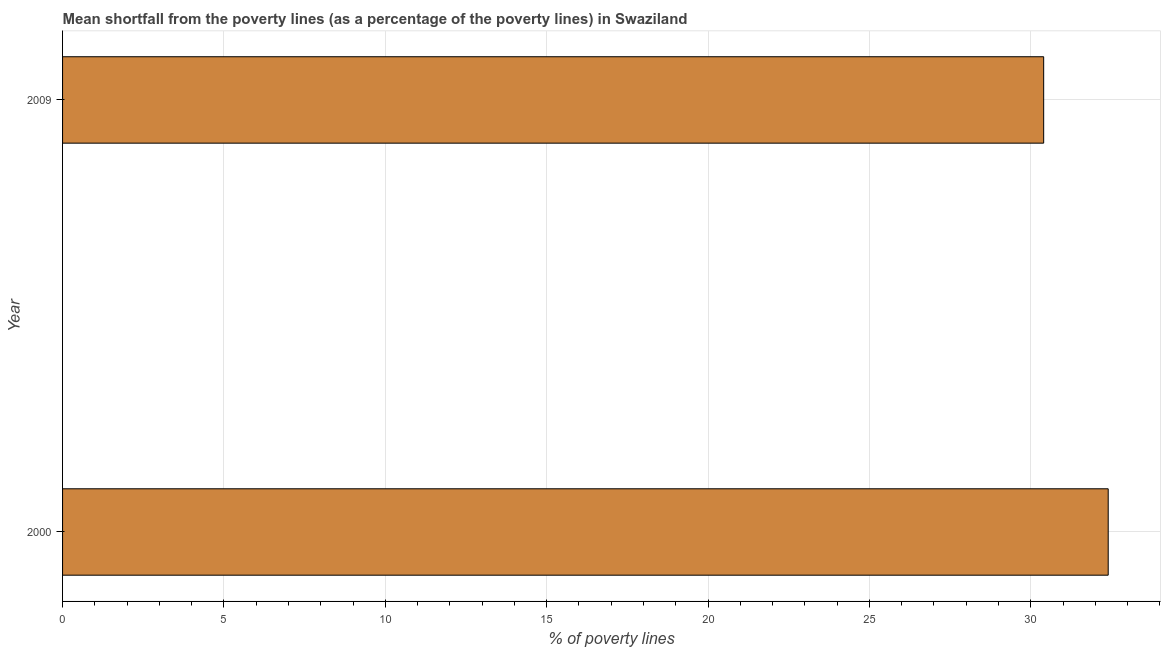What is the title of the graph?
Make the answer very short. Mean shortfall from the poverty lines (as a percentage of the poverty lines) in Swaziland. What is the label or title of the X-axis?
Ensure brevity in your answer.  % of poverty lines. What is the poverty gap at national poverty lines in 2000?
Your answer should be very brief. 32.4. Across all years, what is the maximum poverty gap at national poverty lines?
Your answer should be compact. 32.4. Across all years, what is the minimum poverty gap at national poverty lines?
Your answer should be very brief. 30.4. In which year was the poverty gap at national poverty lines maximum?
Your answer should be compact. 2000. In which year was the poverty gap at national poverty lines minimum?
Offer a very short reply. 2009. What is the sum of the poverty gap at national poverty lines?
Provide a succinct answer. 62.8. What is the difference between the poverty gap at national poverty lines in 2000 and 2009?
Offer a terse response. 2. What is the average poverty gap at national poverty lines per year?
Your answer should be compact. 31.4. What is the median poverty gap at national poverty lines?
Give a very brief answer. 31.4. In how many years, is the poverty gap at national poverty lines greater than 15 %?
Offer a very short reply. 2. Do a majority of the years between 2000 and 2009 (inclusive) have poverty gap at national poverty lines greater than 32 %?
Provide a succinct answer. No. What is the ratio of the poverty gap at national poverty lines in 2000 to that in 2009?
Offer a terse response. 1.07. Is the poverty gap at national poverty lines in 2000 less than that in 2009?
Offer a terse response. No. Are all the bars in the graph horizontal?
Provide a short and direct response. Yes. How many years are there in the graph?
Offer a very short reply. 2. What is the difference between two consecutive major ticks on the X-axis?
Make the answer very short. 5. Are the values on the major ticks of X-axis written in scientific E-notation?
Offer a very short reply. No. What is the % of poverty lines in 2000?
Offer a very short reply. 32.4. What is the % of poverty lines in 2009?
Provide a succinct answer. 30.4. What is the difference between the % of poverty lines in 2000 and 2009?
Offer a very short reply. 2. What is the ratio of the % of poverty lines in 2000 to that in 2009?
Your response must be concise. 1.07. 